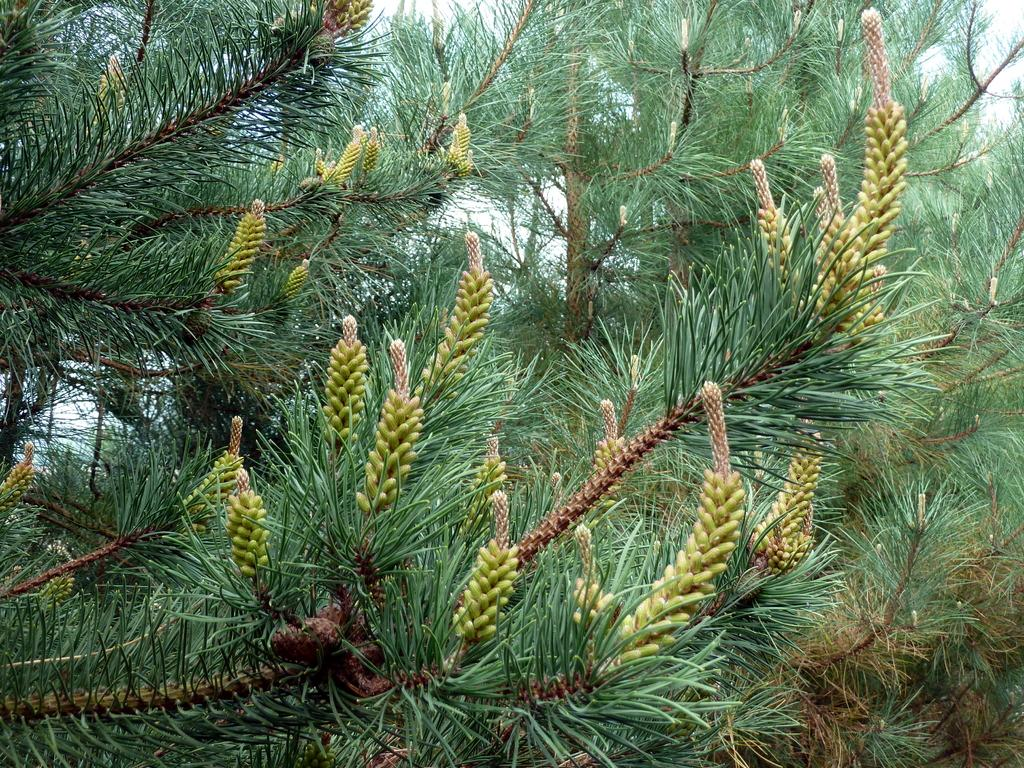What type of vegetation can be seen in the image? There are trees in the image. What is the color of the trees in the image? The trees are green in color. What else is visible in the image besides the trees? There is a sky visible in the image. What is the color of the sky in the image? The sky is white in color. Can you tell me how much the trees have grown since yesterday in the image? The image does not provide information about the growth of the trees since yesterday. --- 